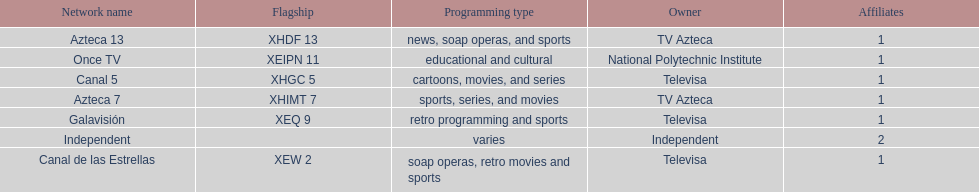What is the only network owned by national polytechnic institute? Once TV. 